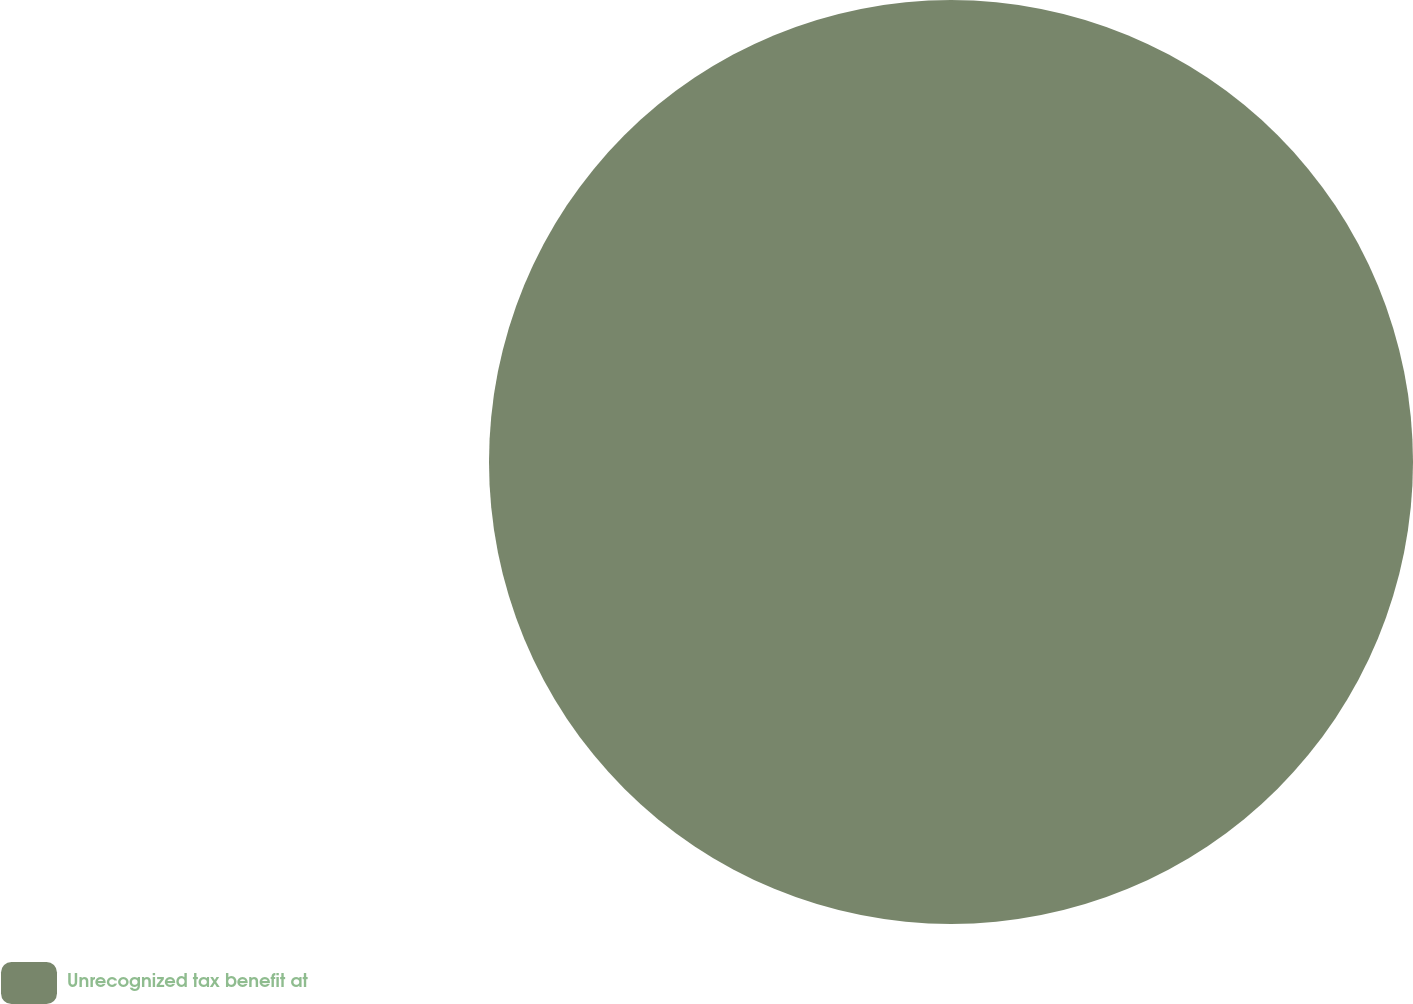Convert chart. <chart><loc_0><loc_0><loc_500><loc_500><pie_chart><fcel>Unrecognized tax benefit at<nl><fcel>100.0%<nl></chart> 